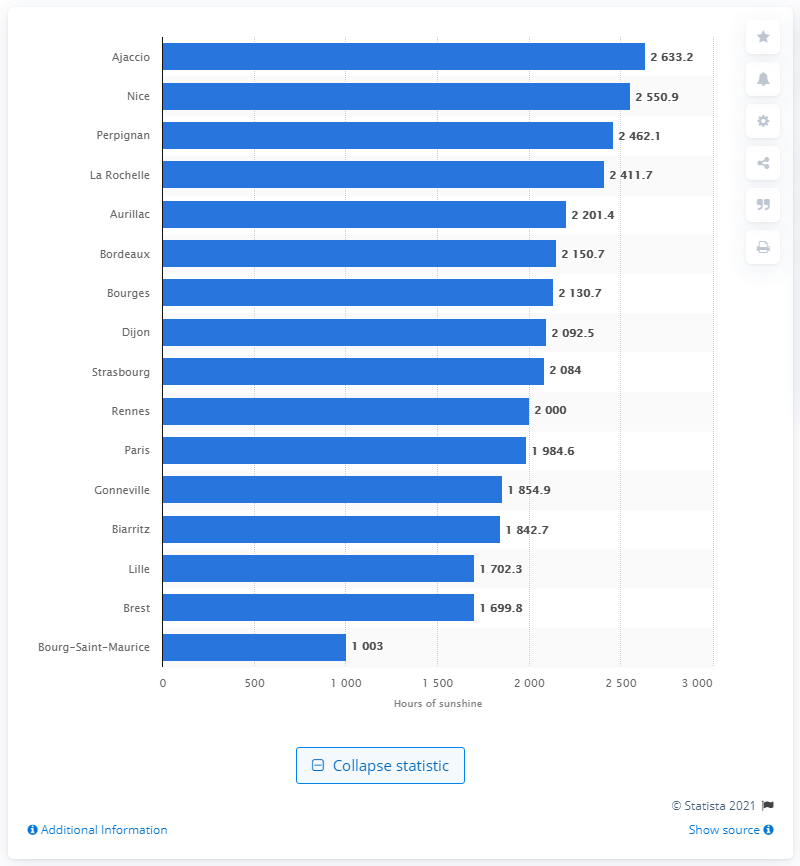Mention a couple of crucial points in this snapshot. According to data from 2018, Ajaccio, a city in France, had the highest number of hours of sunshine among all cities in the country. 